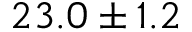Convert formula to latex. <formula><loc_0><loc_0><loc_500><loc_500>2 3 . 0 \pm 1 . 2</formula> 